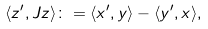<formula> <loc_0><loc_0><loc_500><loc_500>\langle z ^ { \prime } , J z \rangle \colon = \langle x ^ { \prime } , y \rangle - \langle y ^ { \prime } , x \rangle ,</formula> 